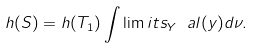Convert formula to latex. <formula><loc_0><loc_0><loc_500><loc_500>h ( S ) = h ( T _ { 1 } ) \int \lim i t s _ { Y } \ a l ( y ) d \nu .</formula> 